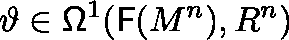<formula> <loc_0><loc_0><loc_500><loc_500>\vartheta \in \Omega ^ { 1 } ( { F } ( M ^ { n } ) , \mathbb { R } ^ { n } )</formula> 